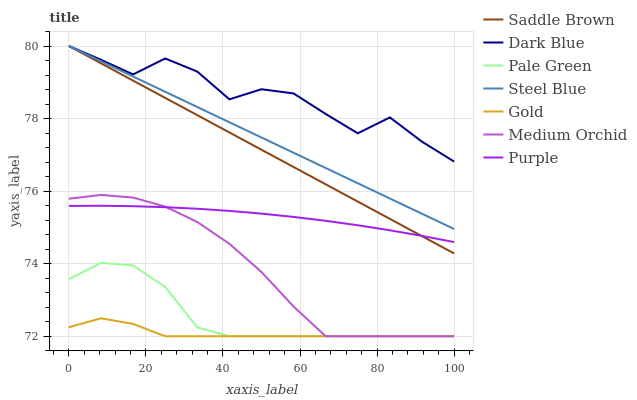Does Gold have the minimum area under the curve?
Answer yes or no. Yes. Does Dark Blue have the maximum area under the curve?
Answer yes or no. Yes. Does Purple have the minimum area under the curve?
Answer yes or no. No. Does Purple have the maximum area under the curve?
Answer yes or no. No. Is Saddle Brown the smoothest?
Answer yes or no. Yes. Is Dark Blue the roughest?
Answer yes or no. Yes. Is Purple the smoothest?
Answer yes or no. No. Is Purple the roughest?
Answer yes or no. No. Does Gold have the lowest value?
Answer yes or no. Yes. Does Purple have the lowest value?
Answer yes or no. No. Does Saddle Brown have the highest value?
Answer yes or no. Yes. Does Purple have the highest value?
Answer yes or no. No. Is Gold less than Steel Blue?
Answer yes or no. Yes. Is Steel Blue greater than Purple?
Answer yes or no. Yes. Does Medium Orchid intersect Pale Green?
Answer yes or no. Yes. Is Medium Orchid less than Pale Green?
Answer yes or no. No. Is Medium Orchid greater than Pale Green?
Answer yes or no. No. Does Gold intersect Steel Blue?
Answer yes or no. No. 